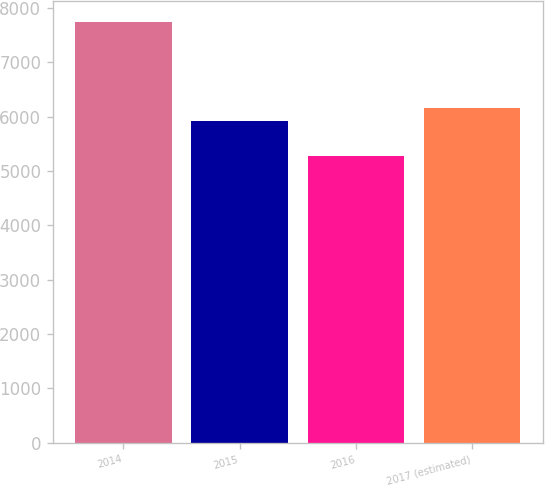Convert chart. <chart><loc_0><loc_0><loc_500><loc_500><bar_chart><fcel>2014<fcel>2015<fcel>2016<fcel>2017 (estimated)<nl><fcel>7739<fcel>5915<fcel>5280<fcel>6160.9<nl></chart> 